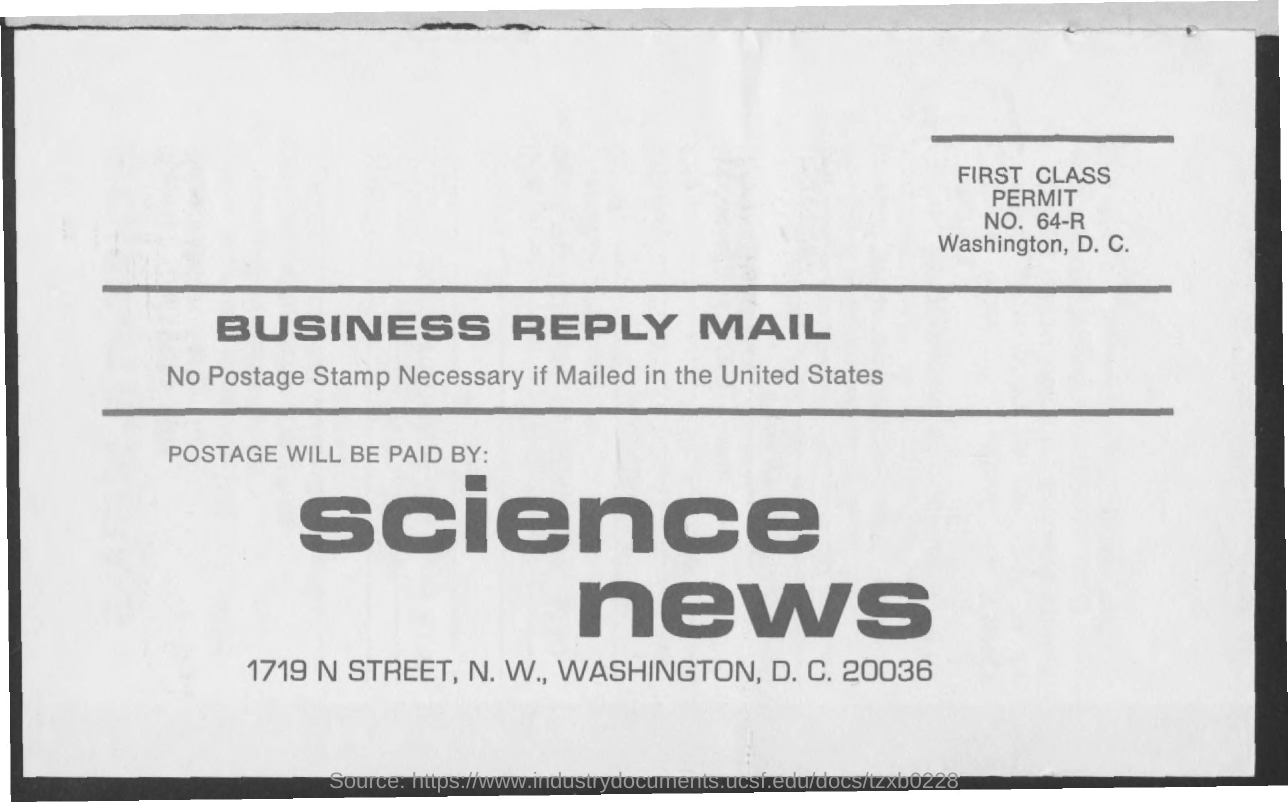Identify some key points in this picture. It is uncertain who will be responsible for paying for postage. 